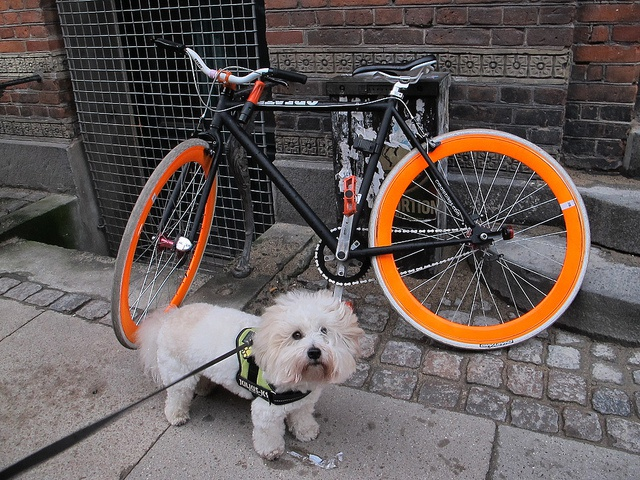Describe the objects in this image and their specific colors. I can see bicycle in brown, black, gray, darkgray, and red tones and dog in brown, darkgray, lightgray, gray, and black tones in this image. 